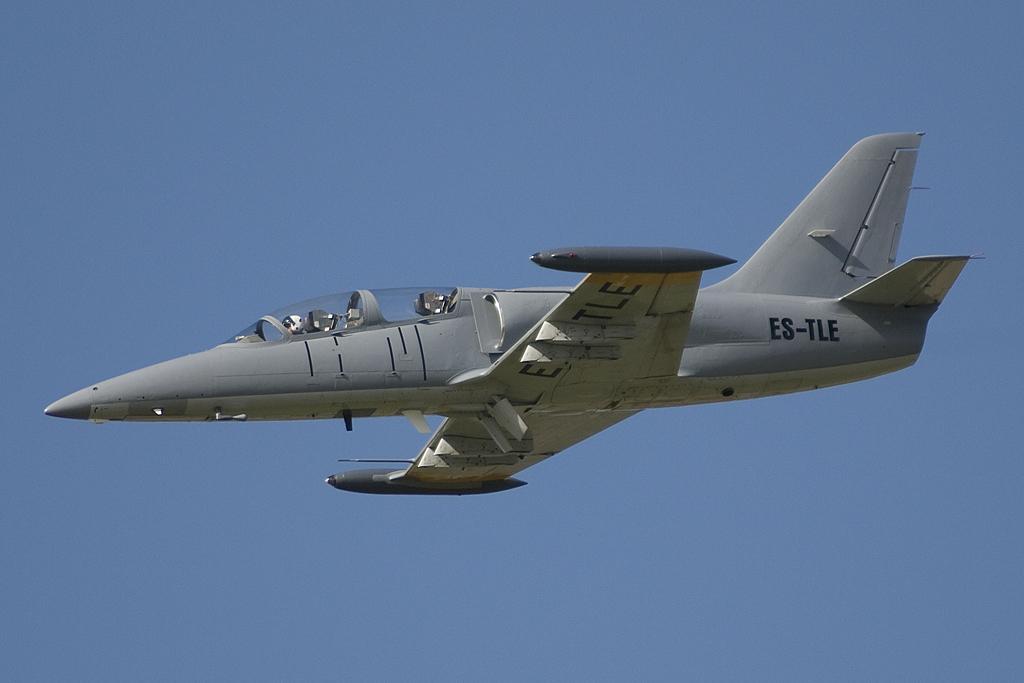In one or two sentences, can you explain what this image depicts? In this picture we can see an aeroplane flying in the air. In the background there is sky. 